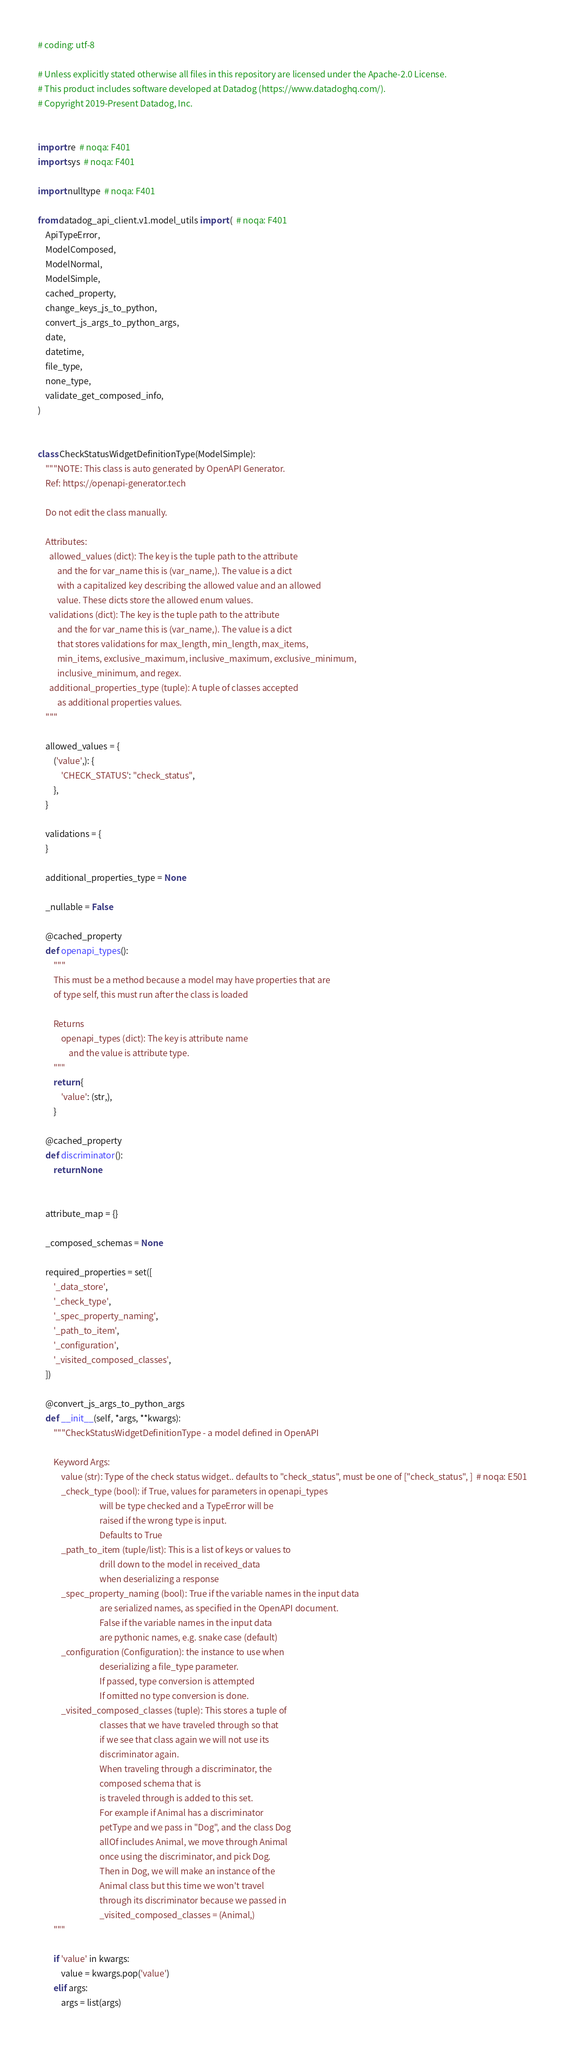<code> <loc_0><loc_0><loc_500><loc_500><_Python_># coding: utf-8

# Unless explicitly stated otherwise all files in this repository are licensed under the Apache-2.0 License.
# This product includes software developed at Datadog (https://www.datadoghq.com/).
# Copyright 2019-Present Datadog, Inc.


import re  # noqa: F401
import sys  # noqa: F401

import nulltype  # noqa: F401

from datadog_api_client.v1.model_utils import (  # noqa: F401
    ApiTypeError,
    ModelComposed,
    ModelNormal,
    ModelSimple,
    cached_property,
    change_keys_js_to_python,
    convert_js_args_to_python_args,
    date,
    datetime,
    file_type,
    none_type,
    validate_get_composed_info,
)


class CheckStatusWidgetDefinitionType(ModelSimple):
    """NOTE: This class is auto generated by OpenAPI Generator.
    Ref: https://openapi-generator.tech

    Do not edit the class manually.

    Attributes:
      allowed_values (dict): The key is the tuple path to the attribute
          and the for var_name this is (var_name,). The value is a dict
          with a capitalized key describing the allowed value and an allowed
          value. These dicts store the allowed enum values.
      validations (dict): The key is the tuple path to the attribute
          and the for var_name this is (var_name,). The value is a dict
          that stores validations for max_length, min_length, max_items,
          min_items, exclusive_maximum, inclusive_maximum, exclusive_minimum,
          inclusive_minimum, and regex.
      additional_properties_type (tuple): A tuple of classes accepted
          as additional properties values.
    """

    allowed_values = {
        ('value',): {
            'CHECK_STATUS': "check_status",
        },
    }

    validations = {
    }

    additional_properties_type = None

    _nullable = False

    @cached_property
    def openapi_types():
        """
        This must be a method because a model may have properties that are
        of type self, this must run after the class is loaded

        Returns
            openapi_types (dict): The key is attribute name
                and the value is attribute type.
        """
        return {
            'value': (str,),
        }

    @cached_property
    def discriminator():
        return None


    attribute_map = {}

    _composed_schemas = None

    required_properties = set([
        '_data_store',
        '_check_type',
        '_spec_property_naming',
        '_path_to_item',
        '_configuration',
        '_visited_composed_classes',
    ])

    @convert_js_args_to_python_args
    def __init__(self, *args, **kwargs):
        """CheckStatusWidgetDefinitionType - a model defined in OpenAPI

        Keyword Args:
            value (str): Type of the check status widget.. defaults to "check_status", must be one of ["check_status", ]  # noqa: E501
            _check_type (bool): if True, values for parameters in openapi_types
                                will be type checked and a TypeError will be
                                raised if the wrong type is input.
                                Defaults to True
            _path_to_item (tuple/list): This is a list of keys or values to
                                drill down to the model in received_data
                                when deserializing a response
            _spec_property_naming (bool): True if the variable names in the input data
                                are serialized names, as specified in the OpenAPI document.
                                False if the variable names in the input data
                                are pythonic names, e.g. snake case (default)
            _configuration (Configuration): the instance to use when
                                deserializing a file_type parameter.
                                If passed, type conversion is attempted
                                If omitted no type conversion is done.
            _visited_composed_classes (tuple): This stores a tuple of
                                classes that we have traveled through so that
                                if we see that class again we will not use its
                                discriminator again.
                                When traveling through a discriminator, the
                                composed schema that is
                                is traveled through is added to this set.
                                For example if Animal has a discriminator
                                petType and we pass in "Dog", and the class Dog
                                allOf includes Animal, we move through Animal
                                once using the discriminator, and pick Dog.
                                Then in Dog, we will make an instance of the
                                Animal class but this time we won't travel
                                through its discriminator because we passed in
                                _visited_composed_classes = (Animal,)
        """

        if 'value' in kwargs:
            value = kwargs.pop('value')
        elif args:
            args = list(args)</code> 